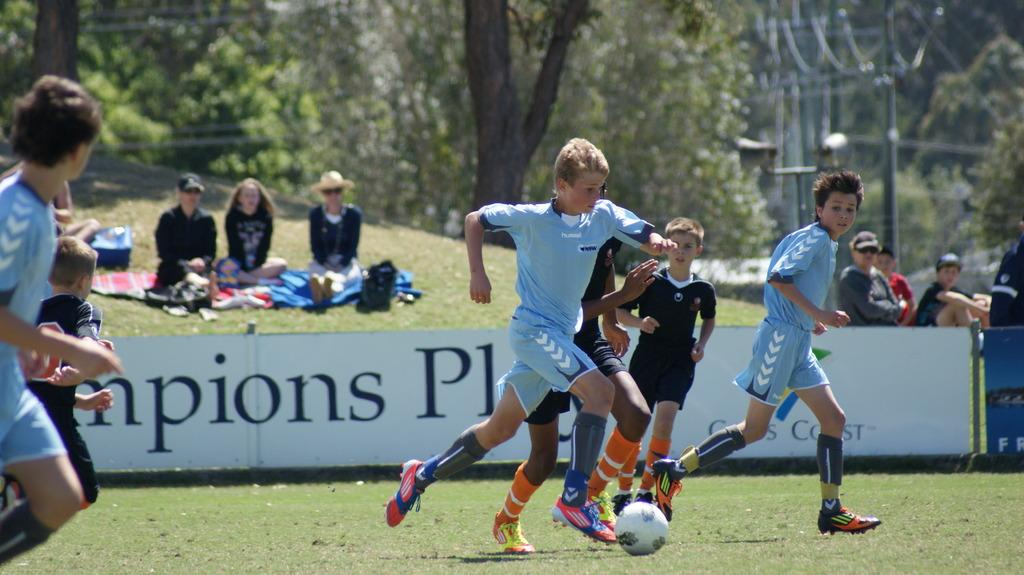What is happening in the image involving a group of people? The boys are playing a game in the ground. What can be seen in the background of the image? There is a hoarding in the image. What are some of the people in the image doing? There are seated people in the image. What other objects are present in the image? There are poles and trees in the image. What type of paste is being used by the people in the image? There is no paste visible or mentioned in the image. How does the image show people expressing hate towards each other? The image does not show any expressions of hate; the boys are playing a game, and there are seated people in the image. 